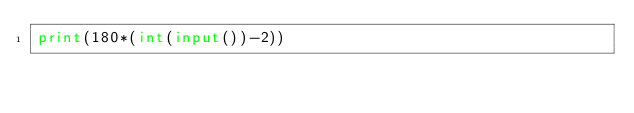<code> <loc_0><loc_0><loc_500><loc_500><_Python_>print(180*(int(input())-2))</code> 